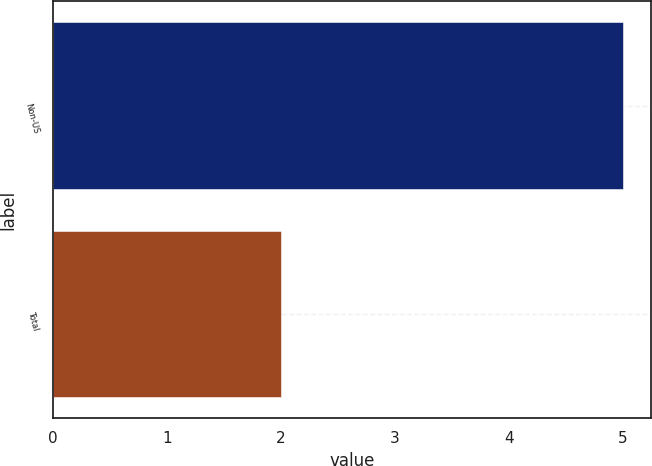<chart> <loc_0><loc_0><loc_500><loc_500><bar_chart><fcel>Non-US<fcel>Total<nl><fcel>5<fcel>2<nl></chart> 